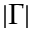<formula> <loc_0><loc_0><loc_500><loc_500>\left | \Gamma \right |</formula> 